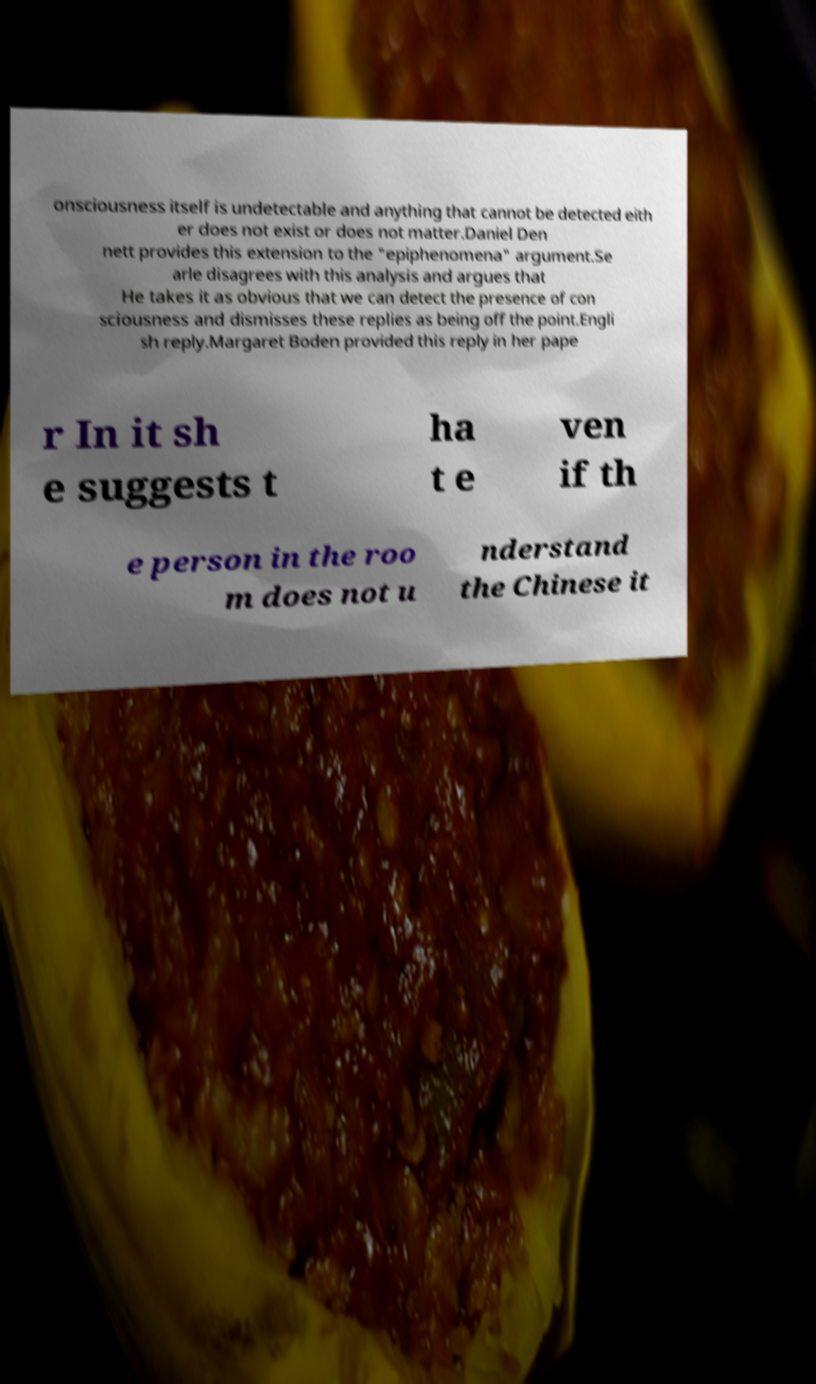Could you extract and type out the text from this image? onsciousness itself is undetectable and anything that cannot be detected eith er does not exist or does not matter.Daniel Den nett provides this extension to the "epiphenomena" argument.Se arle disagrees with this analysis and argues that He takes it as obvious that we can detect the presence of con sciousness and dismisses these replies as being off the point.Engli sh reply.Margaret Boden provided this reply in her pape r In it sh e suggests t ha t e ven if th e person in the roo m does not u nderstand the Chinese it 